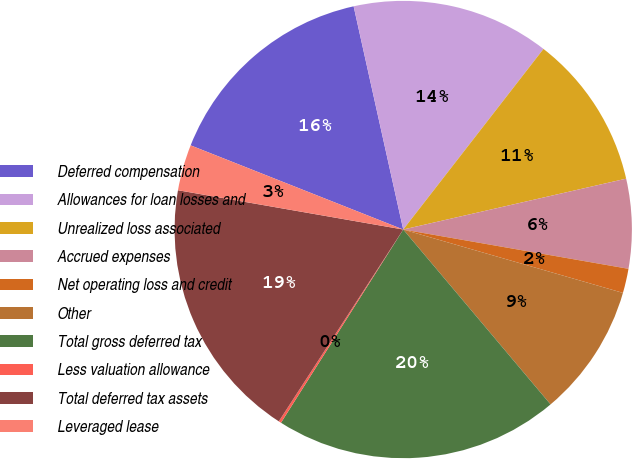Convert chart. <chart><loc_0><loc_0><loc_500><loc_500><pie_chart><fcel>Deferred compensation<fcel>Allowances for loan losses and<fcel>Unrealized loss associated<fcel>Accrued expenses<fcel>Net operating loss and credit<fcel>Other<fcel>Total gross deferred tax<fcel>Less valuation allowance<fcel>Total deferred tax assets<fcel>Leveraged lease<nl><fcel>15.52%<fcel>13.99%<fcel>10.92%<fcel>6.32%<fcel>1.72%<fcel>9.39%<fcel>20.12%<fcel>0.18%<fcel>18.59%<fcel>3.25%<nl></chart> 